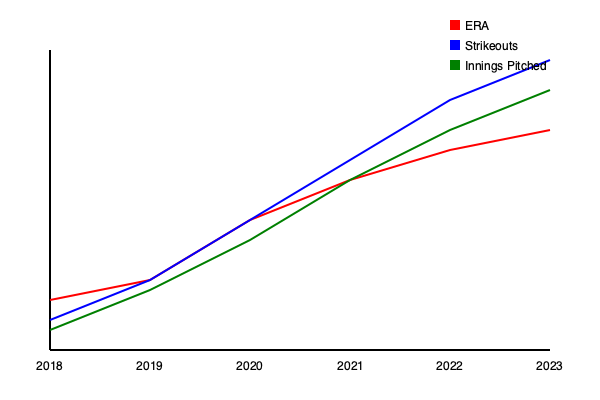Based on the line graph showing a pitcher's key statistics from 2018 to 2023, which aspect of their performance suggests the most significant improvement and potential for future success? To assess the pitcher's career trajectory and potential for future success, we need to analyze the trends in the three key statistics provided:

1. ERA (Earned Run Average):
   - Represented by the red line
   - Shows a steady decrease from 2018 to 2023
   - Lower ERA indicates better performance

2. Strikeouts:
   - Represented by the blue line
   - Shows a significant increase from 2018 to 2023
   - Higher strikeout numbers indicate better performance

3. Innings Pitched:
   - Represented by the green line
   - Shows an increase from 2018 to 2023, but less dramatic than strikeouts
   - More innings pitched generally indicates durability and consistency

Analyzing these trends:

1. The decreasing ERA suggests improved overall effectiveness in preventing runs.
2. The sharp increase in strikeouts indicates a significant improvement in the pitcher's ability to retire batters without allowing balls in play.
3. The gradual increase in innings pitched shows growing endurance and reliability.

While all three statistics show improvement, the most dramatic and promising trend is in the strikeouts. This aspect of the pitcher's performance has shown the steepest improvement over the years, suggesting a developing ability to dominate batters. High strikeout rates are highly valued in modern baseball as they minimize the impact of defense and luck on the pitcher's performance.

The combination of increasing strikeouts, decreasing ERA, and gradually increasing innings pitched all point to a positive career trajectory. However, the strikeout trend stands out as the most significant indicator of the pitcher's improving skills and potential for future success.
Answer: Strikeouts 